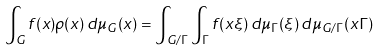<formula> <loc_0><loc_0><loc_500><loc_500>\int _ { G } f ( x ) \rho ( x ) \, d \mu _ { G } ( x ) = \int _ { G / \Gamma } \int _ { \Gamma } f ( x \xi ) \, d \mu _ { \Gamma } ( \xi ) \, d \mu _ { G / \Gamma } ( x \Gamma )</formula> 